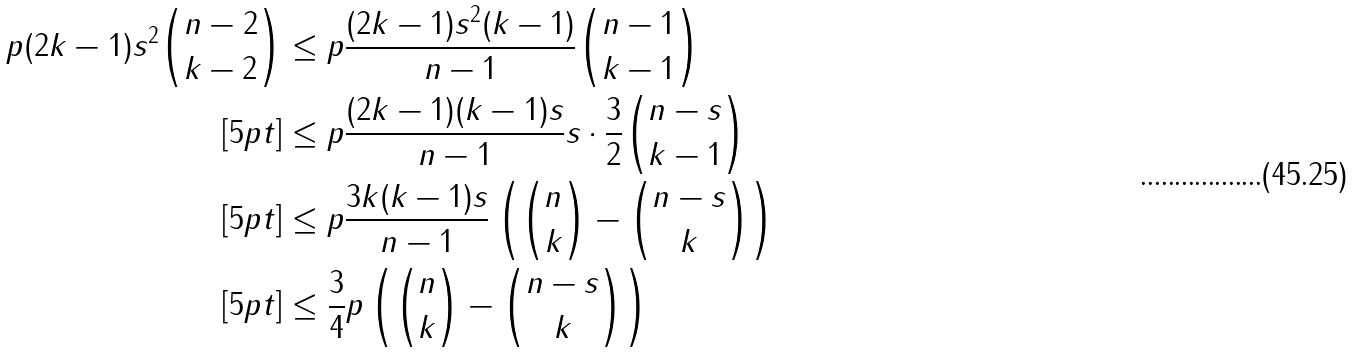Convert formula to latex. <formula><loc_0><loc_0><loc_500><loc_500>p ( 2 k - 1 ) s ^ { 2 } \binom { n - 2 } { k - 2 } & \leq p \frac { ( 2 k - 1 ) s ^ { 2 } ( k - 1 ) } { n - 1 } \binom { n - 1 } { k - 1 } \\ [ 5 p t ] & \leq p \frac { ( 2 k - 1 ) ( k - 1 ) s } { n - 1 } s \cdot \frac { 3 } { 2 } \binom { n - s } { k - 1 } \\ [ 5 p t ] & \leq p \frac { 3 k ( k - 1 ) s } { n - 1 } \left ( \binom { n } { k } - \binom { n - s } { k } \right ) \\ [ 5 p t ] & \leq \frac { 3 } { 4 } p \left ( \binom { n } { k } - \binom { n - s } { k } \right )</formula> 